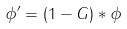<formula> <loc_0><loc_0><loc_500><loc_500>\phi ^ { \prime } = ( 1 - G ) * \phi</formula> 